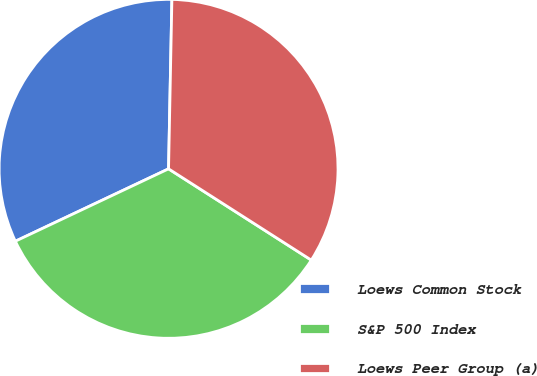Convert chart. <chart><loc_0><loc_0><loc_500><loc_500><pie_chart><fcel>Loews Common Stock<fcel>S&P 500 Index<fcel>Loews Peer Group (a)<nl><fcel>32.34%<fcel>33.92%<fcel>33.74%<nl></chart> 